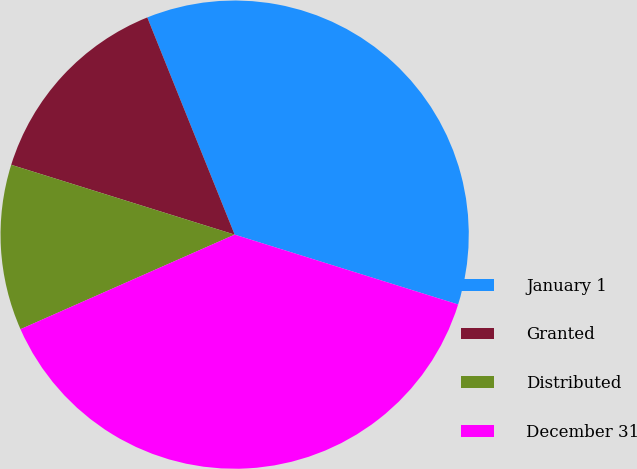Convert chart. <chart><loc_0><loc_0><loc_500><loc_500><pie_chart><fcel>January 1<fcel>Granted<fcel>Distributed<fcel>December 31<nl><fcel>35.91%<fcel>14.09%<fcel>11.44%<fcel>38.56%<nl></chart> 